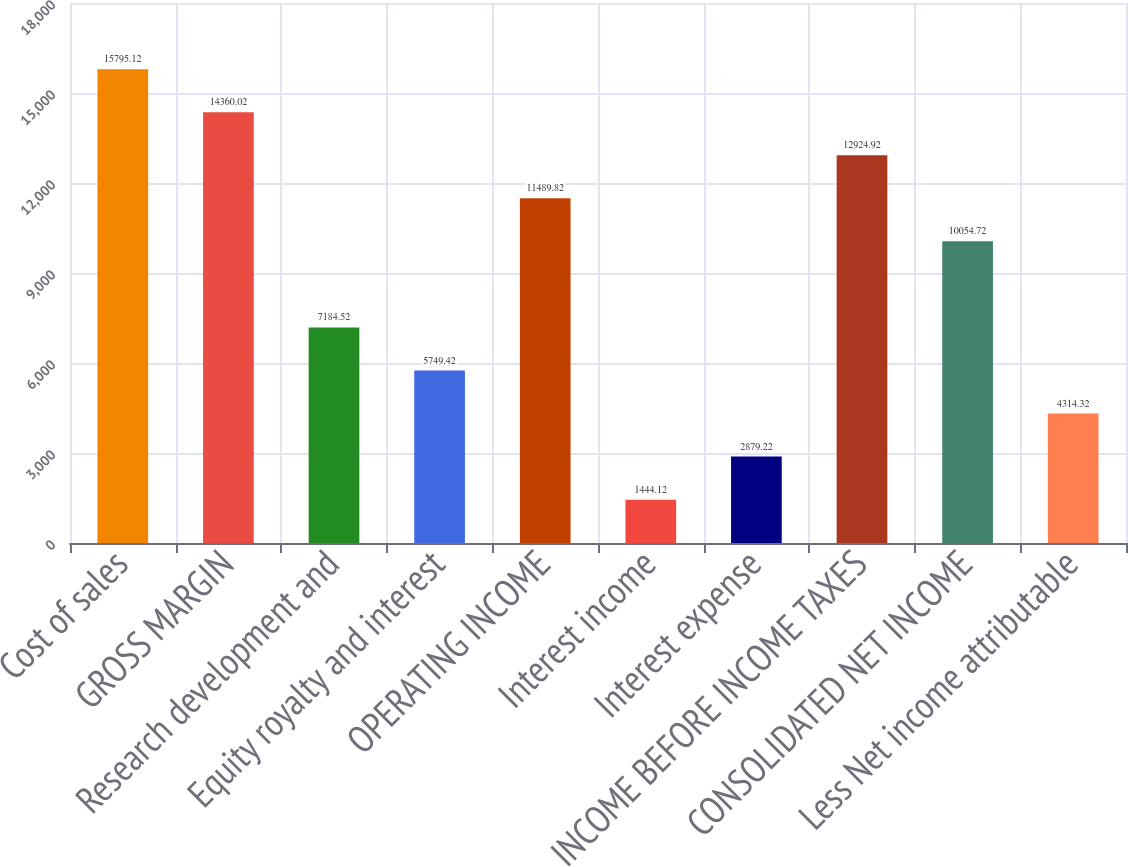Convert chart to OTSL. <chart><loc_0><loc_0><loc_500><loc_500><bar_chart><fcel>Cost of sales<fcel>GROSS MARGIN<fcel>Research development and<fcel>Equity royalty and interest<fcel>OPERATING INCOME<fcel>Interest income<fcel>Interest expense<fcel>INCOME BEFORE INCOME TAXES<fcel>CONSOLIDATED NET INCOME<fcel>Less Net income attributable<nl><fcel>15795.1<fcel>14360<fcel>7184.52<fcel>5749.42<fcel>11489.8<fcel>1444.12<fcel>2879.22<fcel>12924.9<fcel>10054.7<fcel>4314.32<nl></chart> 